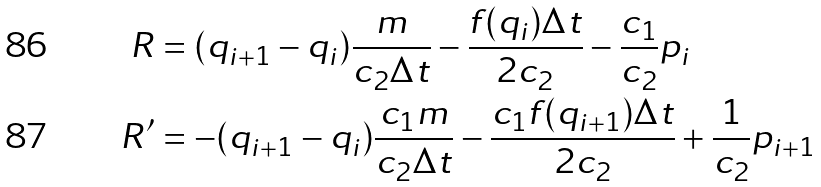Convert formula to latex. <formula><loc_0><loc_0><loc_500><loc_500>R & = ( q _ { i + 1 } - q _ { i } ) \frac { m } { c _ { 2 } \Delta t } - \frac { f ( q _ { i } ) \Delta t } { 2 c _ { 2 } } - \frac { c _ { 1 } } { c _ { 2 } } p _ { i } \\ R ^ { \prime } & = - ( q _ { i + 1 } - q _ { i } ) \frac { c _ { 1 } m } { c _ { 2 } \Delta t } - \frac { c _ { 1 } f ( q _ { i + 1 } ) \Delta t } { 2 c _ { 2 } } + \frac { 1 } { c _ { 2 } } p _ { i + 1 }</formula> 